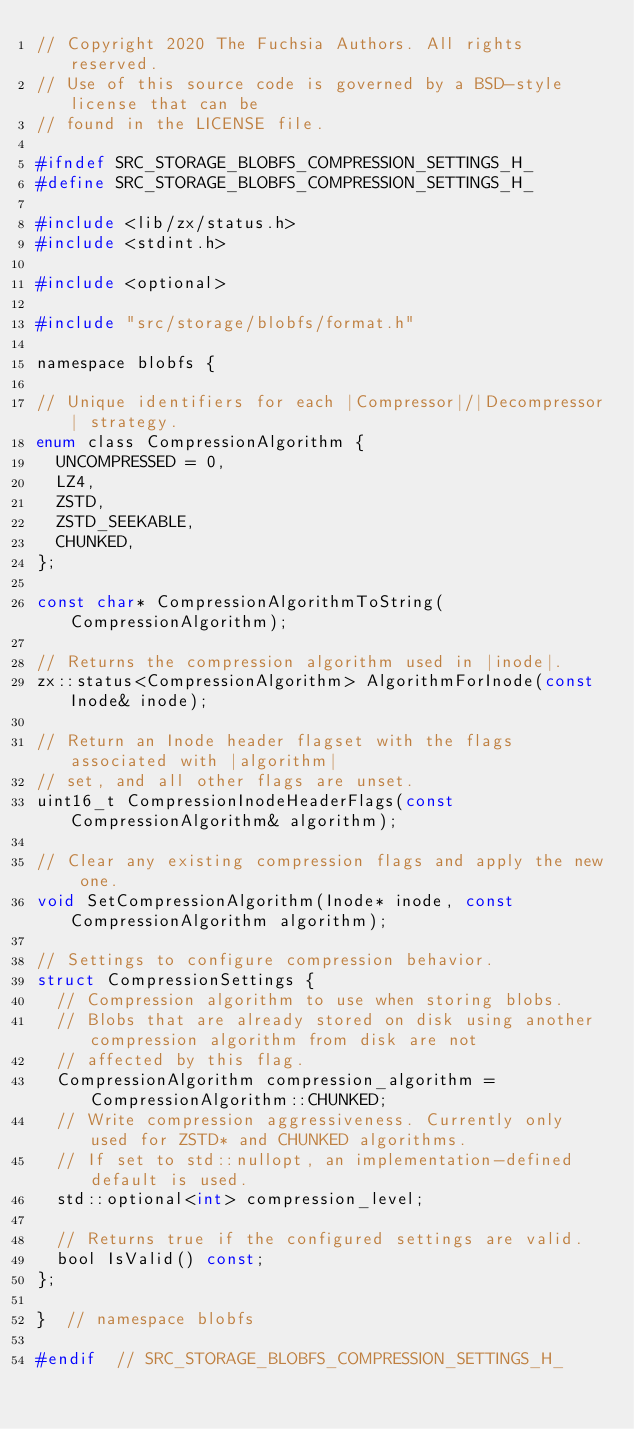Convert code to text. <code><loc_0><loc_0><loc_500><loc_500><_C_>// Copyright 2020 The Fuchsia Authors. All rights reserved.
// Use of this source code is governed by a BSD-style license that can be
// found in the LICENSE file.

#ifndef SRC_STORAGE_BLOBFS_COMPRESSION_SETTINGS_H_
#define SRC_STORAGE_BLOBFS_COMPRESSION_SETTINGS_H_

#include <lib/zx/status.h>
#include <stdint.h>

#include <optional>

#include "src/storage/blobfs/format.h"

namespace blobfs {

// Unique identifiers for each |Compressor|/|Decompressor| strategy.
enum class CompressionAlgorithm {
  UNCOMPRESSED = 0,
  LZ4,
  ZSTD,
  ZSTD_SEEKABLE,
  CHUNKED,
};

const char* CompressionAlgorithmToString(CompressionAlgorithm);

// Returns the compression algorithm used in |inode|.
zx::status<CompressionAlgorithm> AlgorithmForInode(const Inode& inode);

// Return an Inode header flagset with the flags associated with |algorithm|
// set, and all other flags are unset.
uint16_t CompressionInodeHeaderFlags(const CompressionAlgorithm& algorithm);

// Clear any existing compression flags and apply the new one.
void SetCompressionAlgorithm(Inode* inode, const CompressionAlgorithm algorithm);

// Settings to configure compression behavior.
struct CompressionSettings {
  // Compression algorithm to use when storing blobs.
  // Blobs that are already stored on disk using another compression algorithm from disk are not
  // affected by this flag.
  CompressionAlgorithm compression_algorithm = CompressionAlgorithm::CHUNKED;
  // Write compression aggressiveness. Currently only used for ZSTD* and CHUNKED algorithms.
  // If set to std::nullopt, an implementation-defined default is used.
  std::optional<int> compression_level;

  // Returns true if the configured settings are valid.
  bool IsValid() const;
};

}  // namespace blobfs

#endif  // SRC_STORAGE_BLOBFS_COMPRESSION_SETTINGS_H_
</code> 